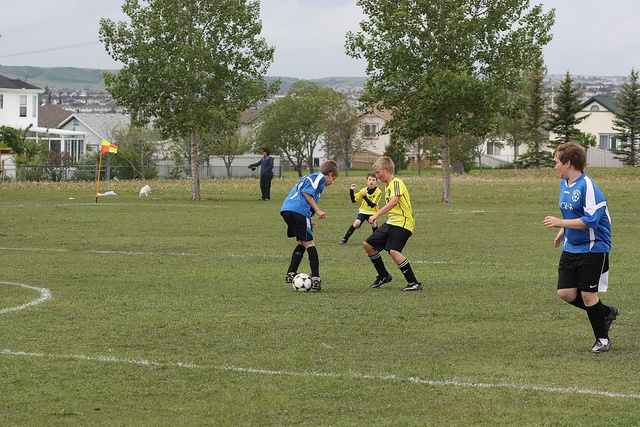Describe the objects in this image and their specific colors. I can see people in lavender, black, blue, navy, and gray tones, people in lavender, black, olive, gray, and blue tones, people in lavender, black, khaki, olive, and brown tones, people in lavender, black, khaki, tan, and olive tones, and people in lavender, black, gray, and darkgray tones in this image. 